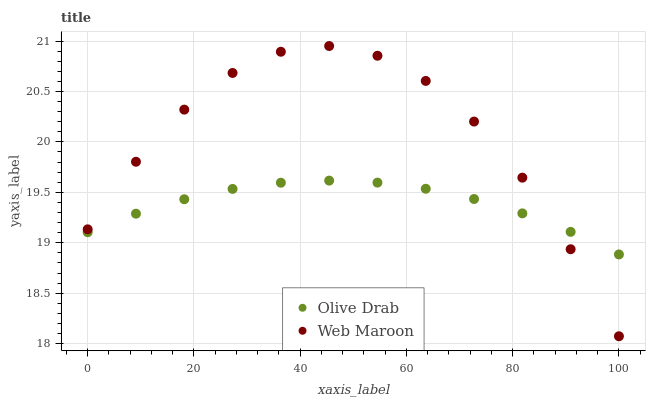Does Olive Drab have the minimum area under the curve?
Answer yes or no. Yes. Does Web Maroon have the maximum area under the curve?
Answer yes or no. Yes. Does Olive Drab have the maximum area under the curve?
Answer yes or no. No. Is Olive Drab the smoothest?
Answer yes or no. Yes. Is Web Maroon the roughest?
Answer yes or no. Yes. Is Olive Drab the roughest?
Answer yes or no. No. Does Web Maroon have the lowest value?
Answer yes or no. Yes. Does Olive Drab have the lowest value?
Answer yes or no. No. Does Web Maroon have the highest value?
Answer yes or no. Yes. Does Olive Drab have the highest value?
Answer yes or no. No. Does Olive Drab intersect Web Maroon?
Answer yes or no. Yes. Is Olive Drab less than Web Maroon?
Answer yes or no. No. Is Olive Drab greater than Web Maroon?
Answer yes or no. No. 